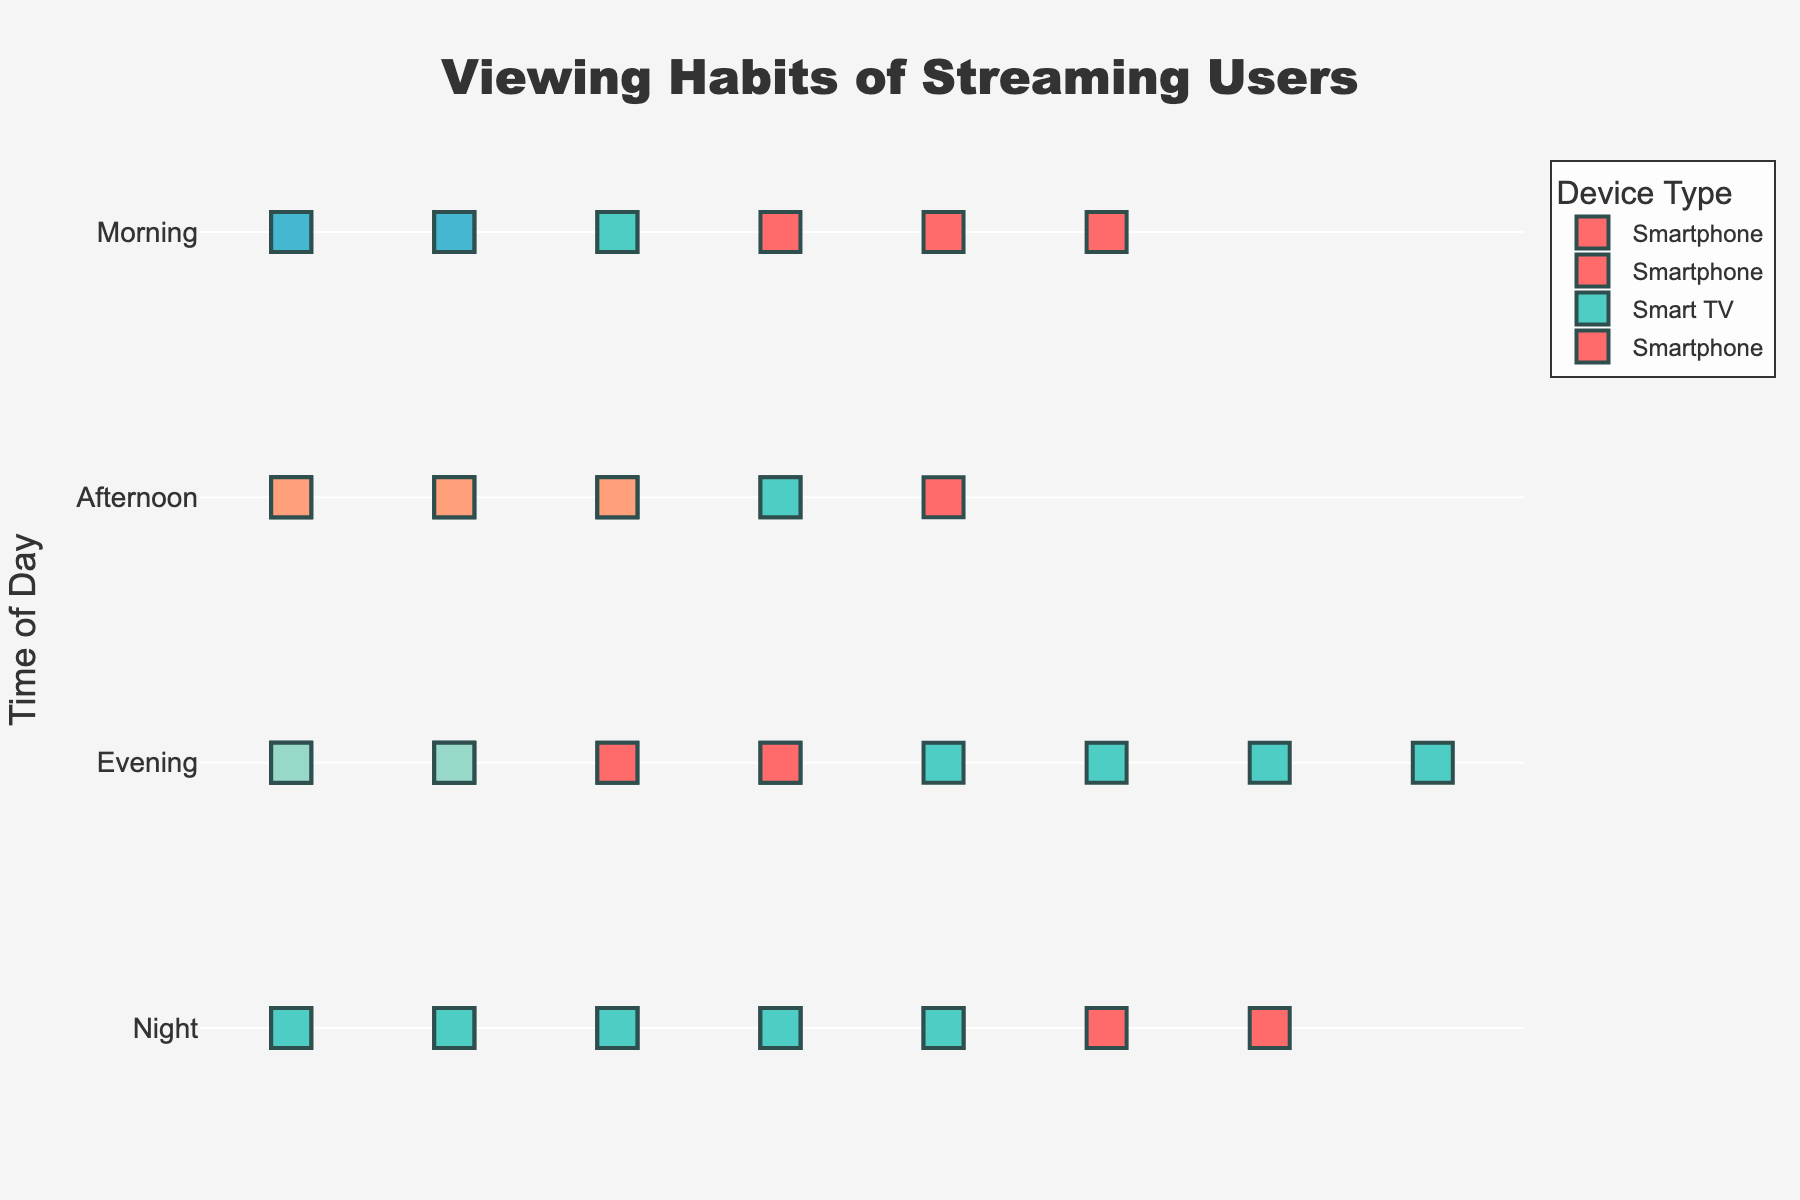What is the title of the plot? The title is located at the top of the plot and provides a clear indication of the figure's focus. The title reads "Viewing Habits of Streaming Users".
Answer: Viewing Habits of Streaming Users How many user icons are at "Morning" for Smart TV? To find the number of user icons for Smart TV in the "Morning," look at the row labeled "Morning" and identify the number of Smart TV icons, which are colored in a specific hue. There are 3 icons (each representing ~5 users, hence 15 users).
Answer: 3 icons During which time of the day is smartphone usage the highest? Compare the number of smartphone icons across different times of day. The "Night" time has the most smartphone icons.
Answer: Night What is the total number of users viewing on Smart TV across all times of day? Sum the number of users represented by Smart TV icons across all times of day: Morning (15), Afternoon (20), Evening (40), Night (25). The total sum is 15 + 20 + 40 + 25 = 100.
Answer: 100 users Which device has the least number of users in the evening? In the "Evening" row, compare the number of user icons for each device. The Game Console has the fewest icons, indicating the least number of users.
Answer: Game Console What is the difference in the number of users viewing on Smartphones between Morning and Night? Calculate the difference in users between the two times: Morning has 30 users, Night has 35 users. The difference is 35 - 30 = 5.
Answer: 5 users Which time of the day has the most diverse range of devices used? Examine each time of the day to see which has the most distinct device categories. The "Afternoon" has three different devices (Smartphone, Smart TV, Laptop), whereas other times have fewer types.
Answer: Afternoon If you were to average the number of users viewing on a Laptop across all times of day, what would it be? There are users viewing on Laptops in the Afternoon (15) and Night (20). Sum these (15 + 20 = 35) and divide by the number of time periods where Laptops are used (2). The average is 35 / 2 = 17.5.
Answer: 17.5 users What percentage of total users during the "Evening" are using a Smart TV? During the Evening, Smart TV has 40 users out of the total 70 users (Smart TV, Smartphone, and Game Console combined). The percentage is (40 / 70) * 100 = 57.14%.
Answer: 57.14% 